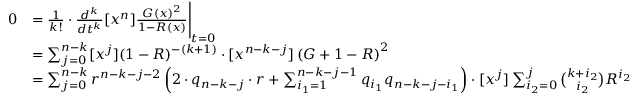Convert formula to latex. <formula><loc_0><loc_0><loc_500><loc_500>\begin{array} { r l } { 0 } & { = \frac { 1 } { k ! } \cdot \frac { d ^ { k } } { d t ^ { k } } [ x ^ { n } ] \frac { G ( x ) ^ { 2 } } { 1 - R ( x ) } \Big | _ { t = 0 } } \\ & { = \sum _ { j = 0 } ^ { n - k } [ x ^ { j } ] ( 1 - R ) ^ { - ( k + 1 ) } \cdot [ x ^ { n - k - j } ] \left ( G + 1 - R \right ) ^ { 2 } } \\ & { = \sum _ { j = 0 } ^ { n - k } r ^ { n - k - j - 2 } \left ( 2 \cdot q _ { n - k - j } \cdot r + \sum _ { i _ { 1 } = 1 } ^ { n - k - j - 1 } q _ { i _ { 1 } } q _ { n - k - j - i _ { 1 } } \right ) \cdot [ x ^ { j } ] \sum _ { i _ { 2 } = 0 } ^ { j } { \binom { k + i _ { 2 } } { i _ { 2 } } } R ^ { i _ { 2 } } } \end{array}</formula> 